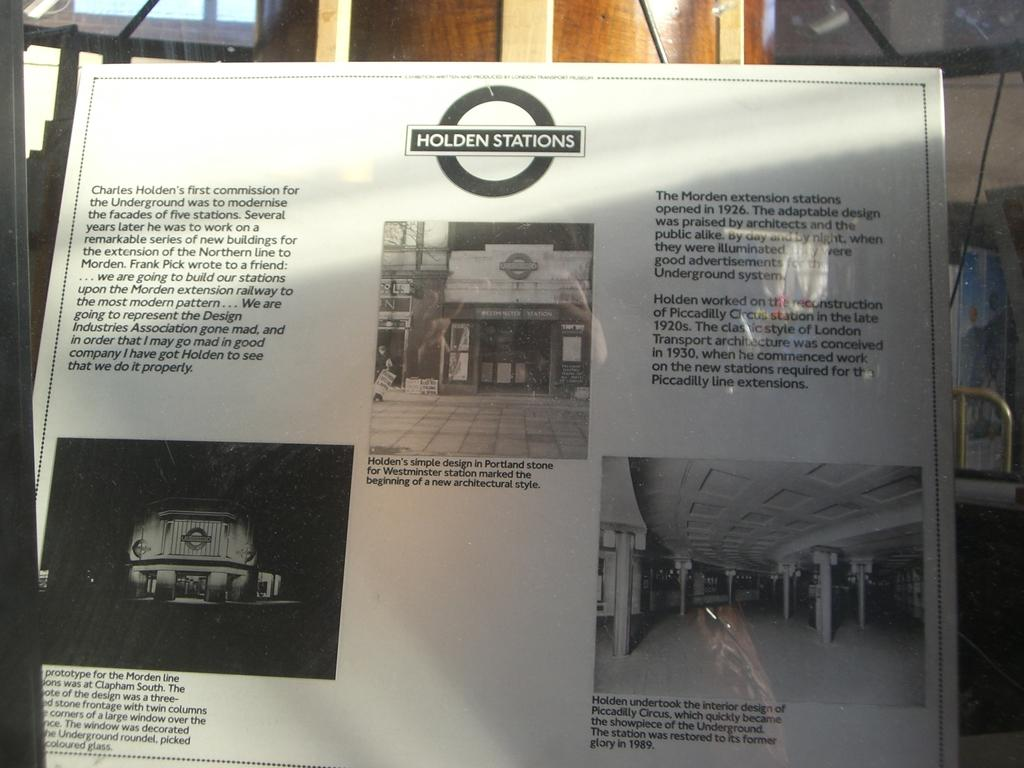<image>
Share a concise interpretation of the image provided. a page showing and describing some of Charles Holden's stations 